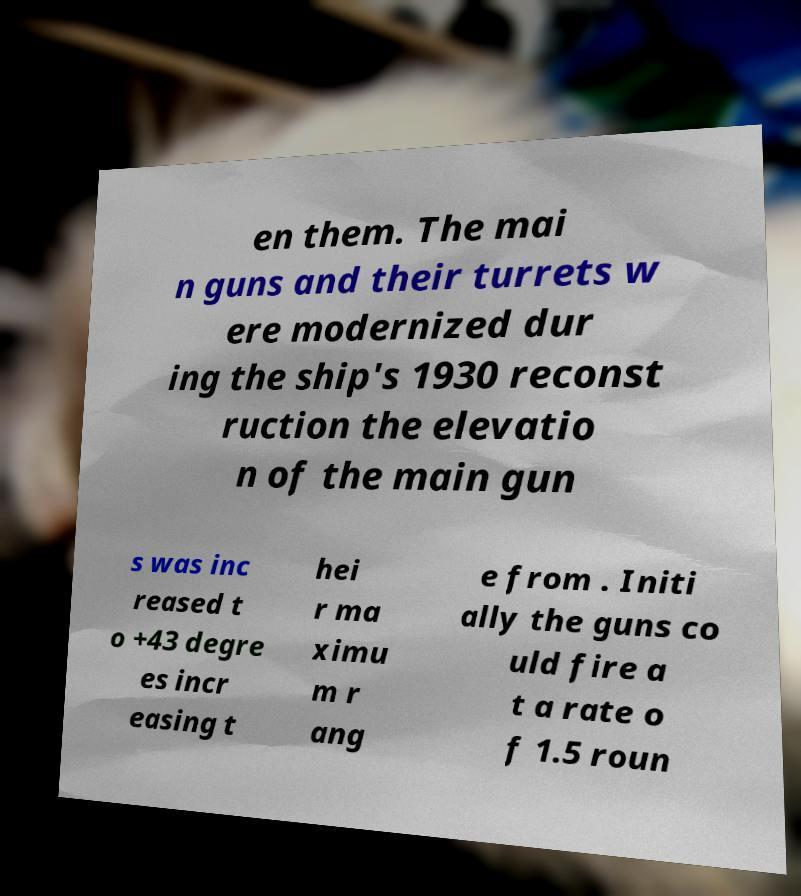For documentation purposes, I need the text within this image transcribed. Could you provide that? en them. The mai n guns and their turrets w ere modernized dur ing the ship's 1930 reconst ruction the elevatio n of the main gun s was inc reased t o +43 degre es incr easing t hei r ma ximu m r ang e from . Initi ally the guns co uld fire a t a rate o f 1.5 roun 